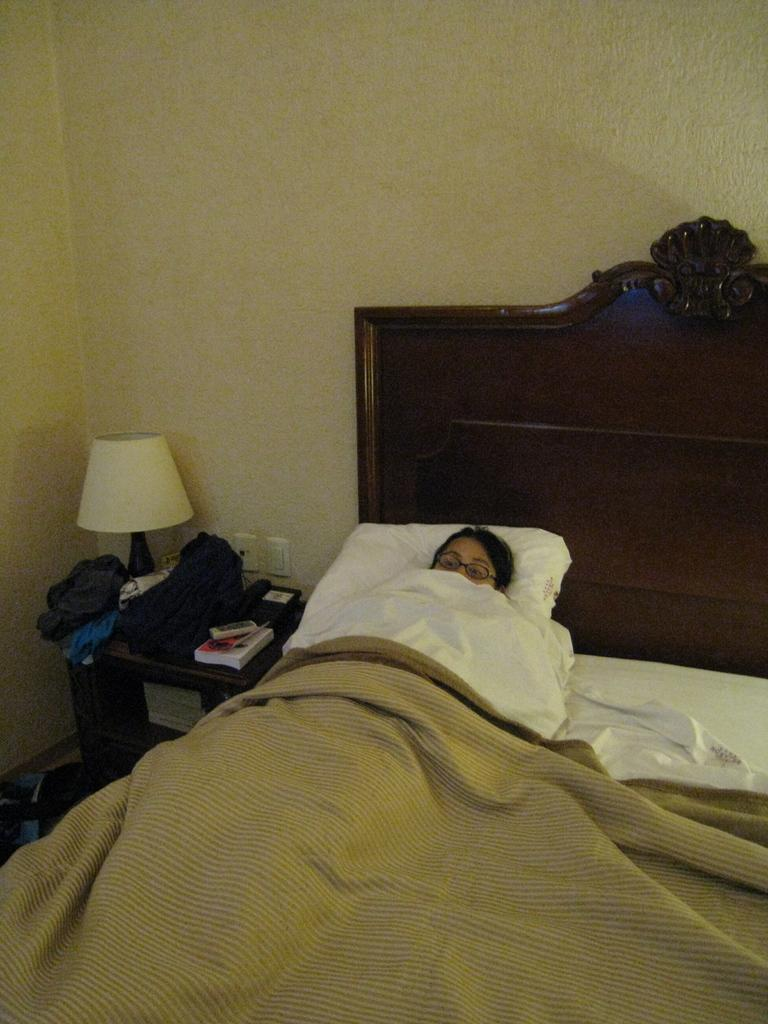What is the woman in the image doing? The woman is sleeping on the bed. What object is present on the wooden table? There is a table lamp on the wooden table. What type of jewel is the woman wearing on her finger in the image? There is no jewel visible on the woman's finger in the image. How does the ice in the image contribute to the invention of a new cooling system? There is no ice present in the image, and therefore it cannot contribute to the invention of a new cooling system. 